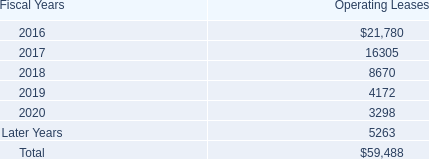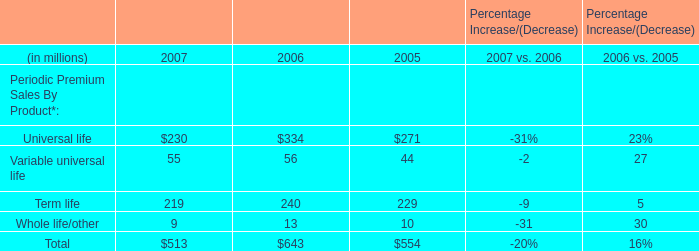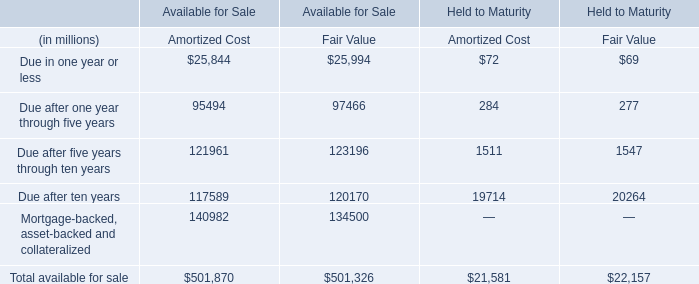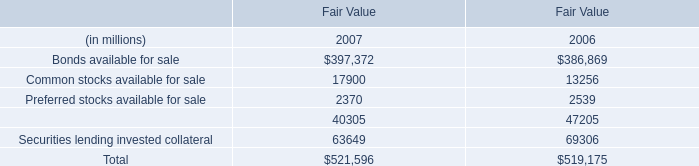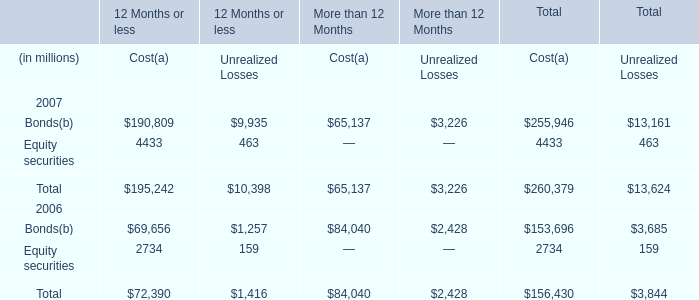What is the sum of Bonds of More than 12 Months Unrealized Losses, Due after ten years of Available for Sale Fair Value, and Bonds available for sale of Fair Value 2006 ? 
Computations: ((3226.0 + 120170.0) + 386869.0)
Answer: 510265.0. 